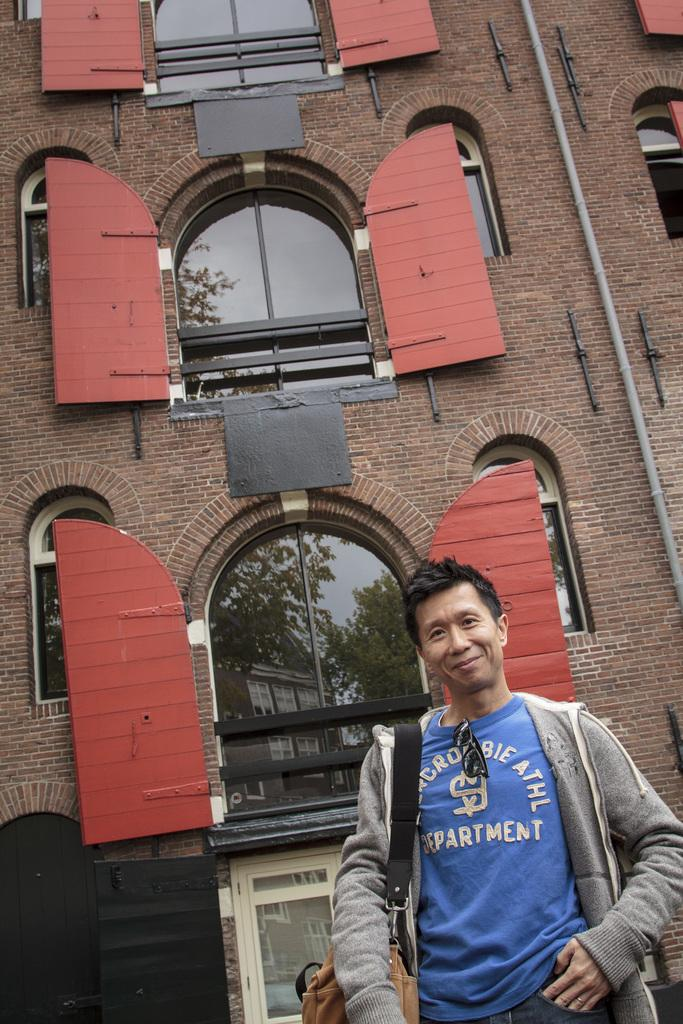What is the main subject of the image? There is a person standing in the image. Can you describe the person's clothing? The person is wearing a grey color jacket. What can be seen in the background of the image? There is a building in the background of the image. What features does the building have? The building has windows and doors attached to its walls. What type of corn is being suggested by the person in the image? There is no corn or suggestion present in the image; it only features a person standing and a building in the background. 